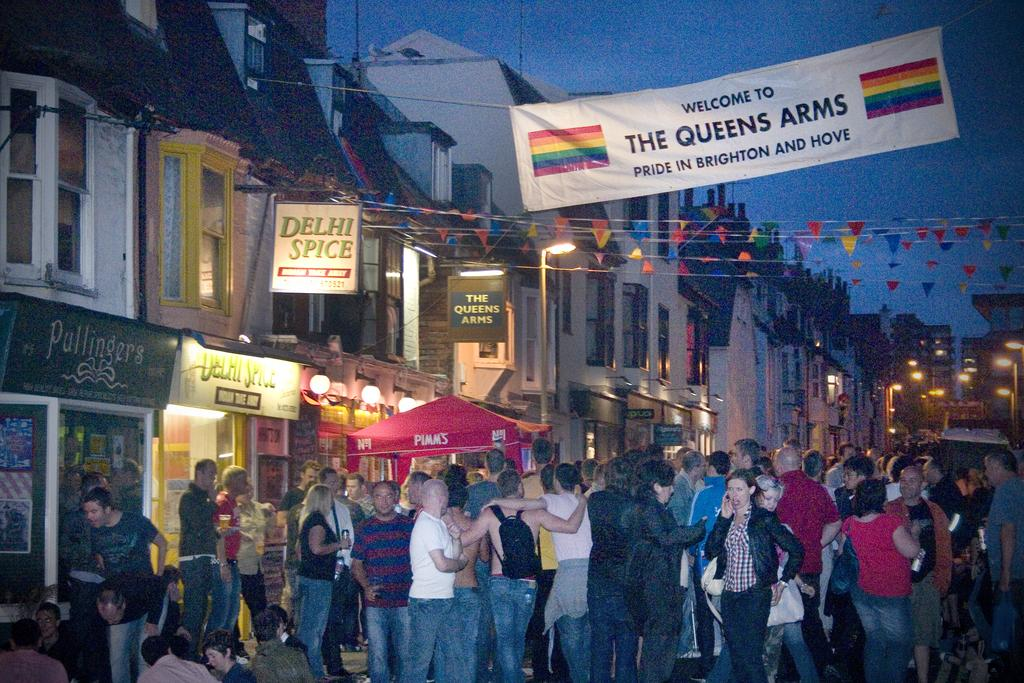What type of structures can be seen in the image? There are buildings with windows in the image. What are some other objects visible in the image? There are light poles, stores, and banners in the image. Are there any people present in the image? Yes, there are people standing in the image. What type of shirt is the building wearing in the image? Buildings do not wear shirts; they are inanimate structures. 